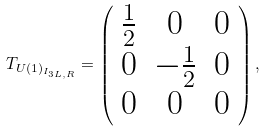Convert formula to latex. <formula><loc_0><loc_0><loc_500><loc_500>T _ { U ( 1 ) _ { I _ { 3 L , R } } } = \left ( \begin{array} { c c c } \frac { 1 } { 2 } & 0 & 0 \\ 0 & - \frac { 1 } { 2 } & 0 \\ 0 & 0 & 0 \end{array} \right ) , \,</formula> 